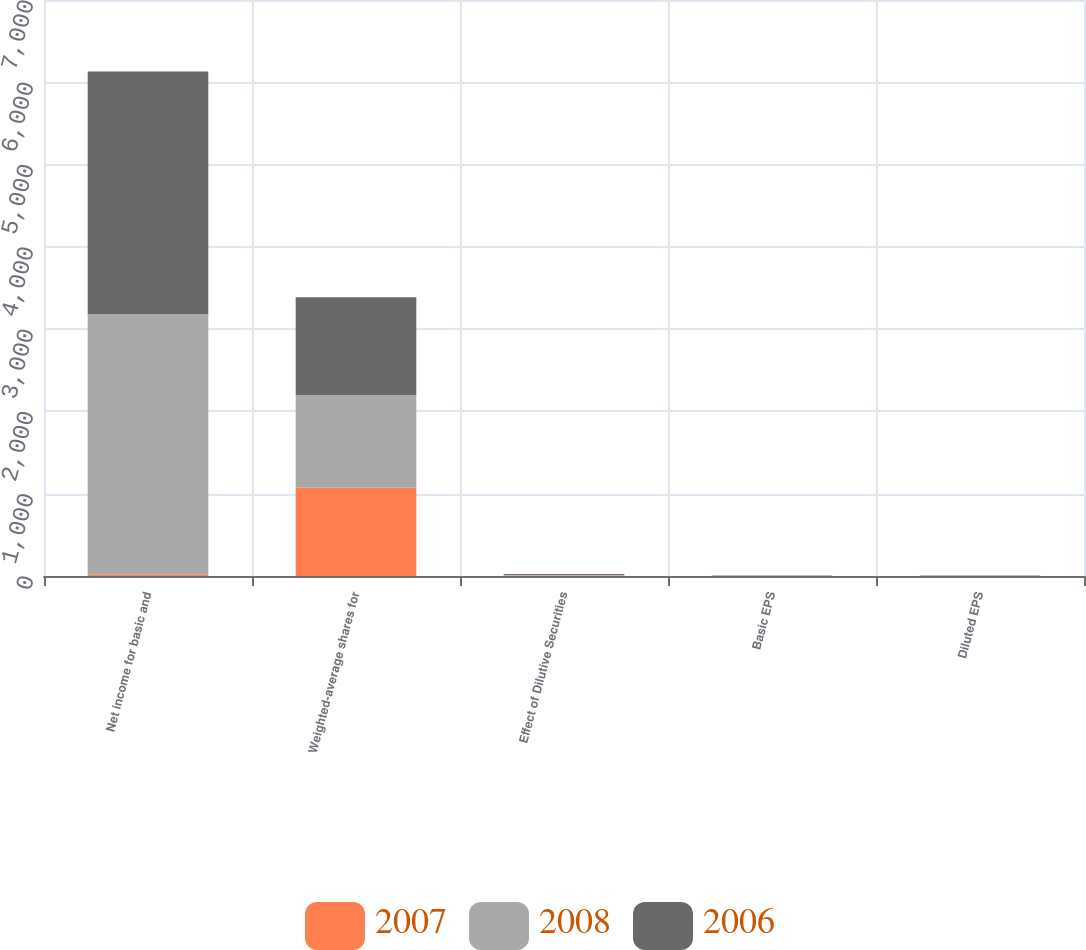<chart> <loc_0><loc_0><loc_500><loc_500><stacked_bar_chart><ecel><fcel>Net income for basic and<fcel>Weighted-average shares for<fcel>Effect of Dilutive Securities<fcel>Basic EPS<fcel>Diluted EPS<nl><fcel>2007<fcel>14<fcel>1075<fcel>5<fcel>3.92<fcel>3.9<nl><fcel>2008<fcel>3166<fcel>1123<fcel>6<fcel>2.83<fcel>2.82<nl><fcel>2006<fcel>2950<fcel>1190<fcel>14<fcel>2.51<fcel>2.48<nl></chart> 